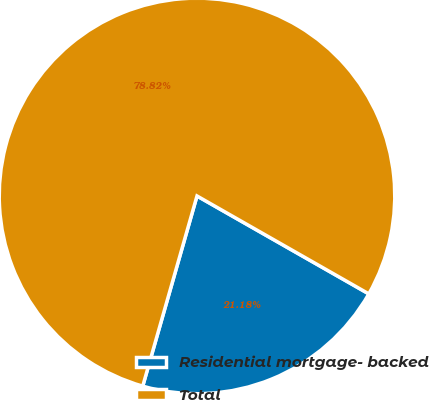<chart> <loc_0><loc_0><loc_500><loc_500><pie_chart><fcel>Residential mortgage- backed<fcel>Total<nl><fcel>21.18%<fcel>78.82%<nl></chart> 